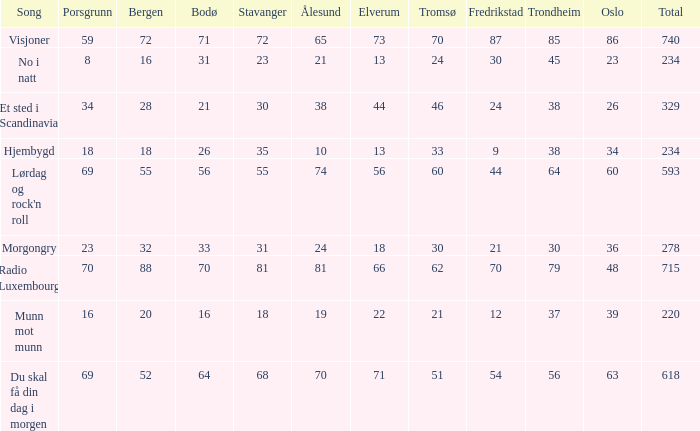What is the smallest overall total? 220.0. 